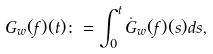<formula> <loc_0><loc_0><loc_500><loc_500>G _ { w } ( f ) ( t ) \colon = \int _ { 0 } ^ { t } \dot { G } _ { w } ( f ) ( s ) d s ,</formula> 